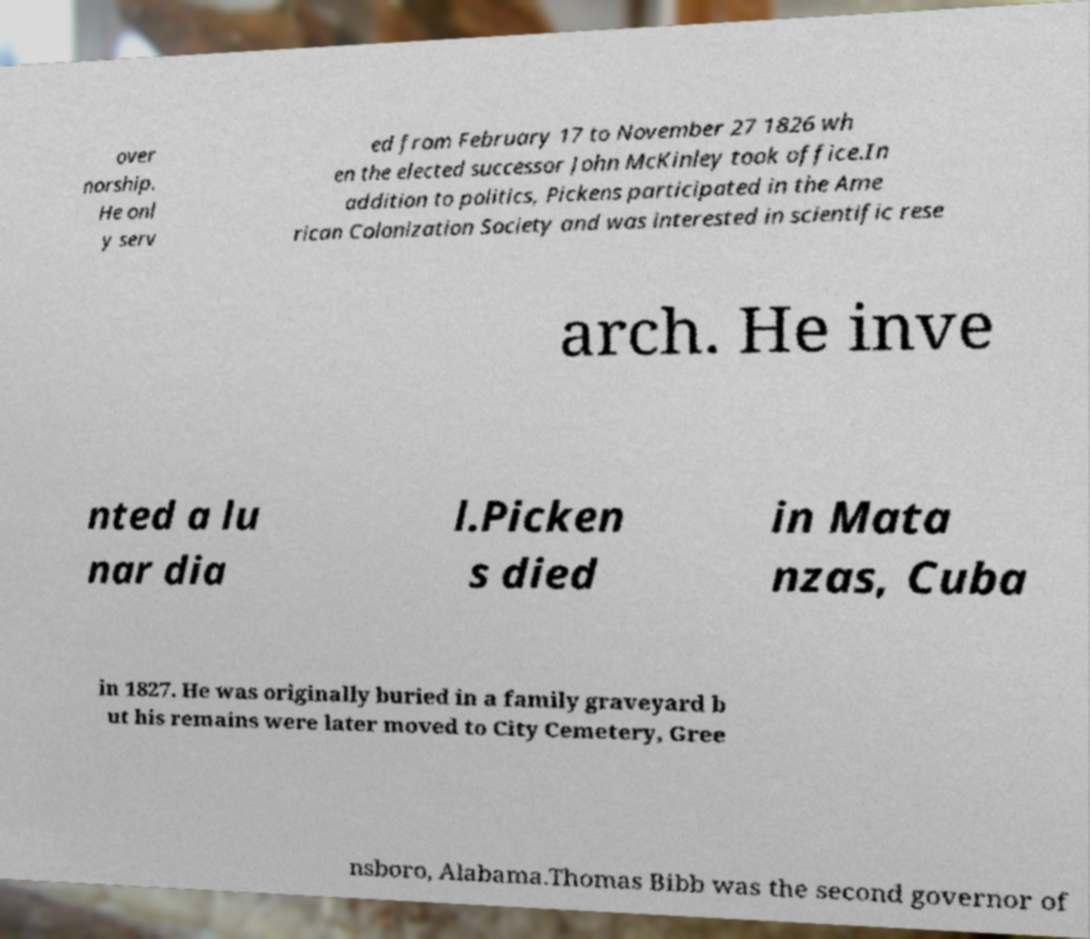Can you accurately transcribe the text from the provided image for me? over norship. He onl y serv ed from February 17 to November 27 1826 wh en the elected successor John McKinley took office.In addition to politics, Pickens participated in the Ame rican Colonization Society and was interested in scientific rese arch. He inve nted a lu nar dia l.Picken s died in Mata nzas, Cuba in 1827. He was originally buried in a family graveyard b ut his remains were later moved to City Cemetery, Gree nsboro, Alabama.Thomas Bibb was the second governor of 